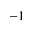<formula> <loc_0><loc_0><loc_500><loc_500>- 1</formula> 